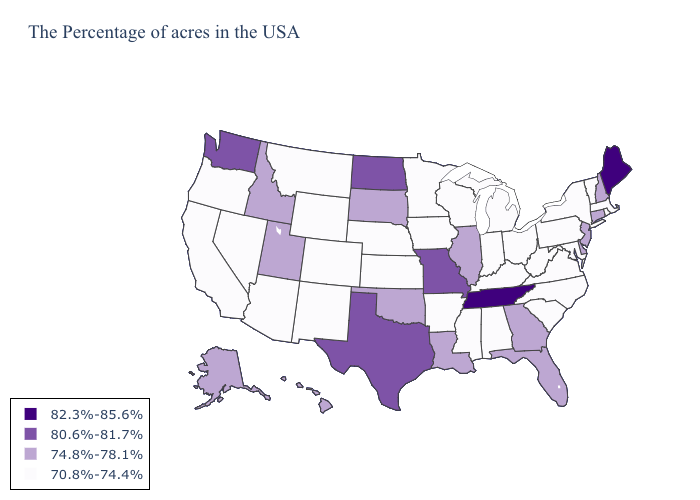What is the value of Nevada?
Concise answer only. 70.8%-74.4%. Does the map have missing data?
Write a very short answer. No. What is the value of Kansas?
Keep it brief. 70.8%-74.4%. Name the states that have a value in the range 82.3%-85.6%?
Give a very brief answer. Maine, Tennessee. Does the map have missing data?
Write a very short answer. No. Among the states that border Wyoming , does Nebraska have the lowest value?
Be succinct. Yes. Which states hav the highest value in the Northeast?
Write a very short answer. Maine. What is the value of New Mexico?
Be succinct. 70.8%-74.4%. Name the states that have a value in the range 80.6%-81.7%?
Short answer required. Missouri, Texas, North Dakota, Washington. Name the states that have a value in the range 80.6%-81.7%?
Give a very brief answer. Missouri, Texas, North Dakota, Washington. Among the states that border Missouri , does Iowa have the lowest value?
Write a very short answer. Yes. Name the states that have a value in the range 74.8%-78.1%?
Quick response, please. New Hampshire, Connecticut, New Jersey, Delaware, Florida, Georgia, Illinois, Louisiana, Oklahoma, South Dakota, Utah, Idaho, Alaska, Hawaii. What is the value of Illinois?
Keep it brief. 74.8%-78.1%. What is the highest value in states that border Nevada?
Write a very short answer. 74.8%-78.1%. What is the value of Kansas?
Keep it brief. 70.8%-74.4%. 